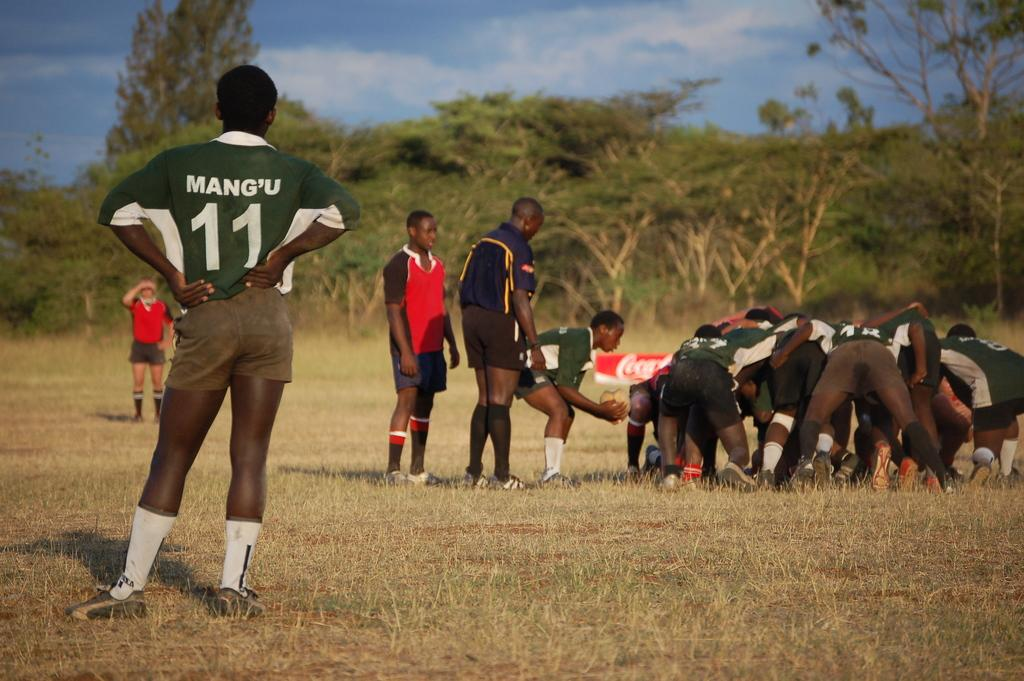<image>
Write a terse but informative summary of the picture. Ruby team that is out in the field playing, one of the players is named Mang'U # 11. 